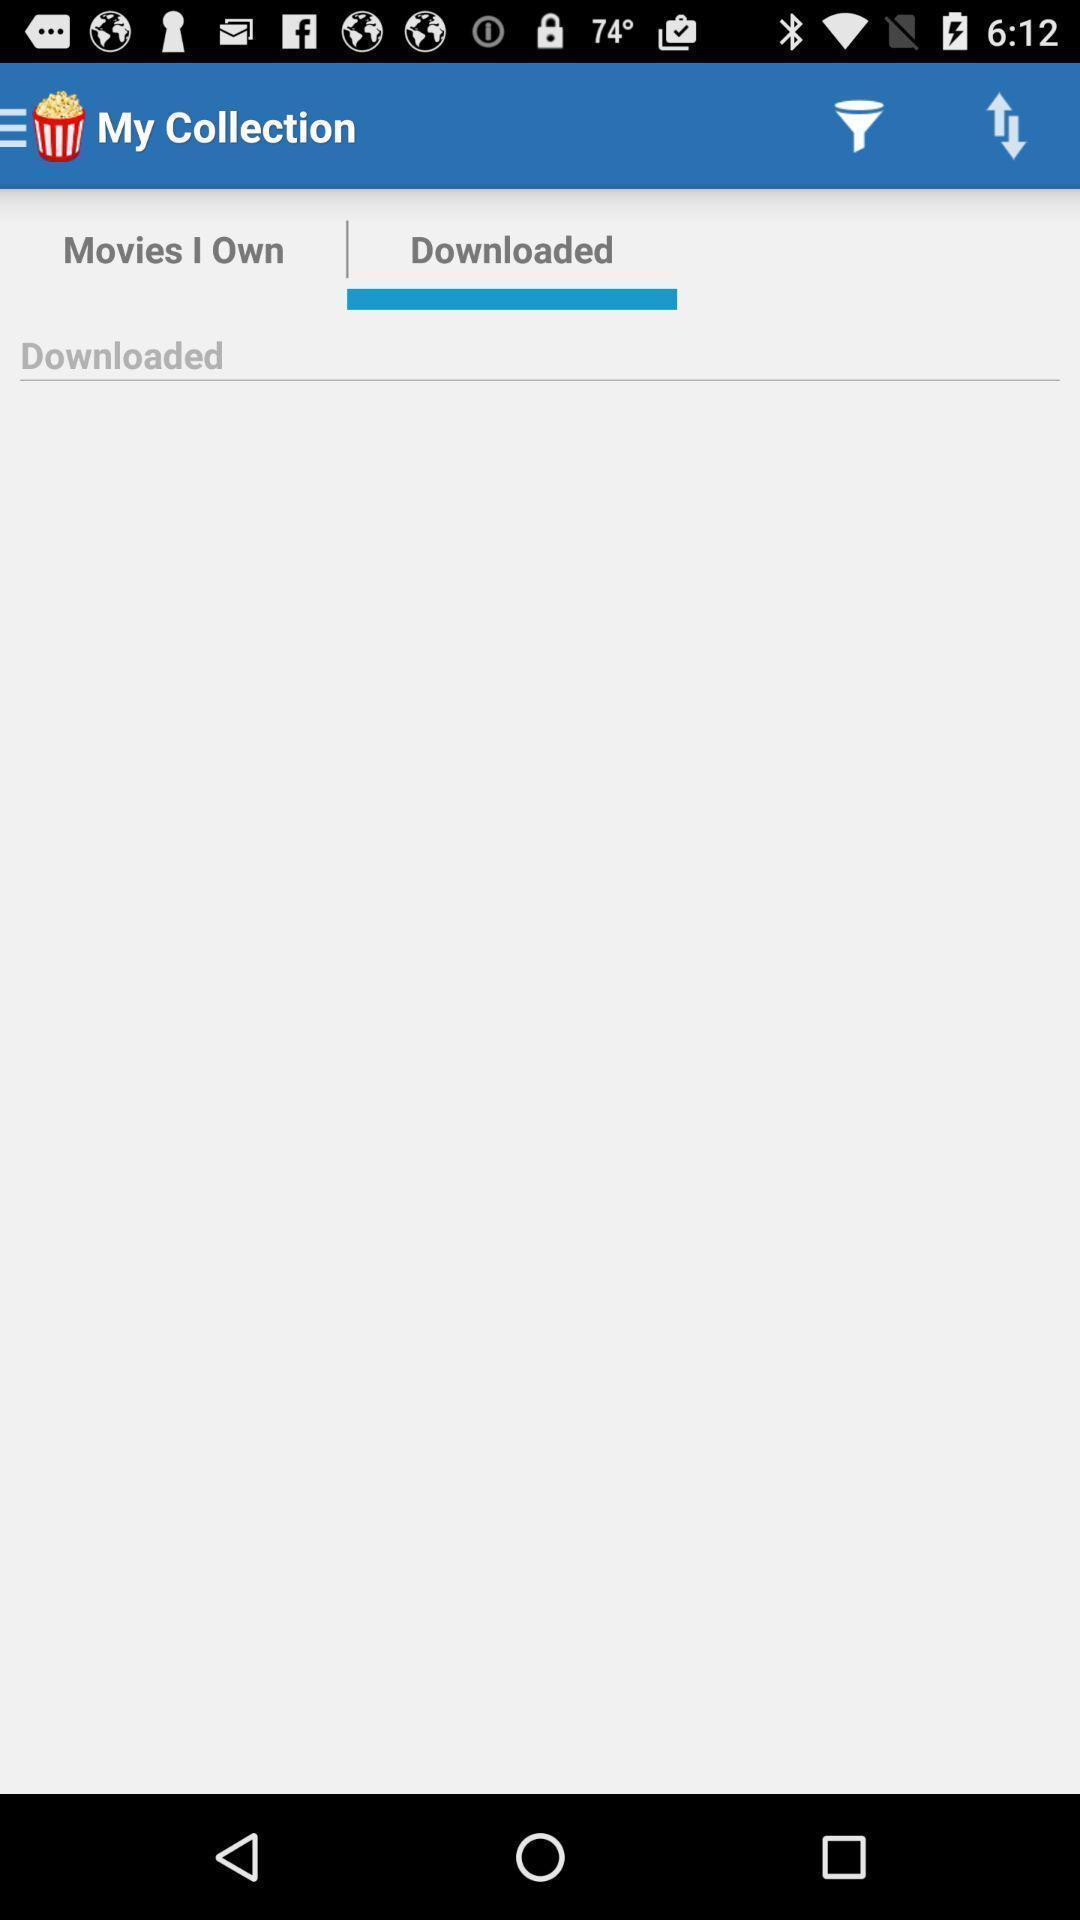What can you discern from this picture? Screen showing the downloaded tab. 